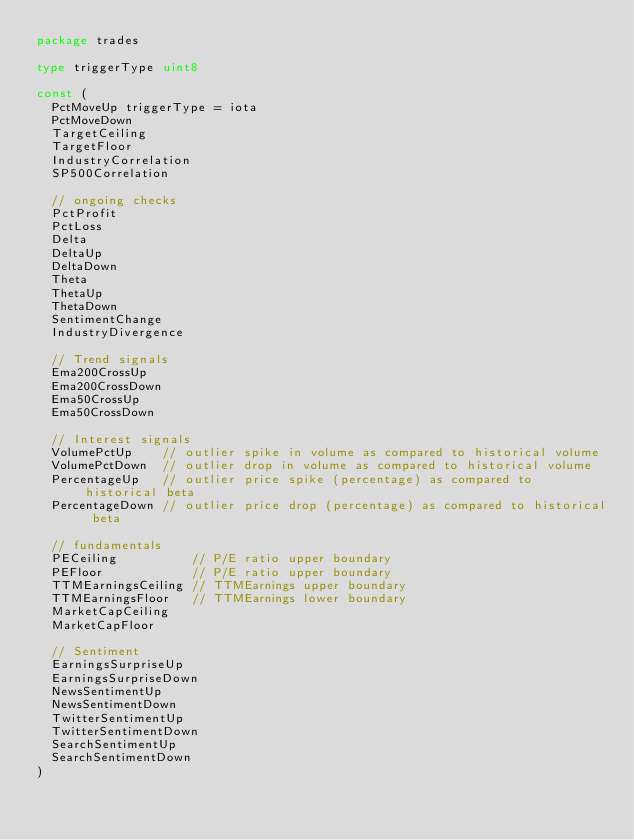Convert code to text. <code><loc_0><loc_0><loc_500><loc_500><_Go_>package trades

type triggerType uint8

const (
	PctMoveUp triggerType = iota
	PctMoveDown
	TargetCeiling
	TargetFloor
	IndustryCorrelation
	SP500Correlation

	// ongoing checks
	PctProfit
	PctLoss
	Delta
	DeltaUp
	DeltaDown
	Theta
	ThetaUp
	ThetaDown
	SentimentChange
	IndustryDivergence

	// Trend signals
	Ema200CrossUp
	Ema200CrossDown
	Ema50CrossUp
	Ema50CrossDown

	// Interest signals
	VolumePctUp    // outlier spike in volume as compared to historical volume
	VolumePctDown  // outlier drop in volume as compared to historical volume
	PercentageUp   // outlier price spike (percentage) as compared to historical beta
	PercentageDown // outlier price drop (percentage) as compared to historical beta

	// fundamentals
	PECeiling          // P/E ratio upper boundary
	PEFloor            // P/E ratio upper boundary
	TTMEarningsCeiling // TTMEarnings upper boundary
	TTMEarningsFloor   // TTMEarnings lower boundary
	MarketCapCeiling
	MarketCapFloor

	// Sentiment
	EarningsSurpriseUp
	EarningsSurpriseDown
	NewsSentimentUp
	NewsSentimentDown
	TwitterSentimentUp
	TwitterSentimentDown
	SearchSentimentUp
	SearchSentimentDown
)
</code> 